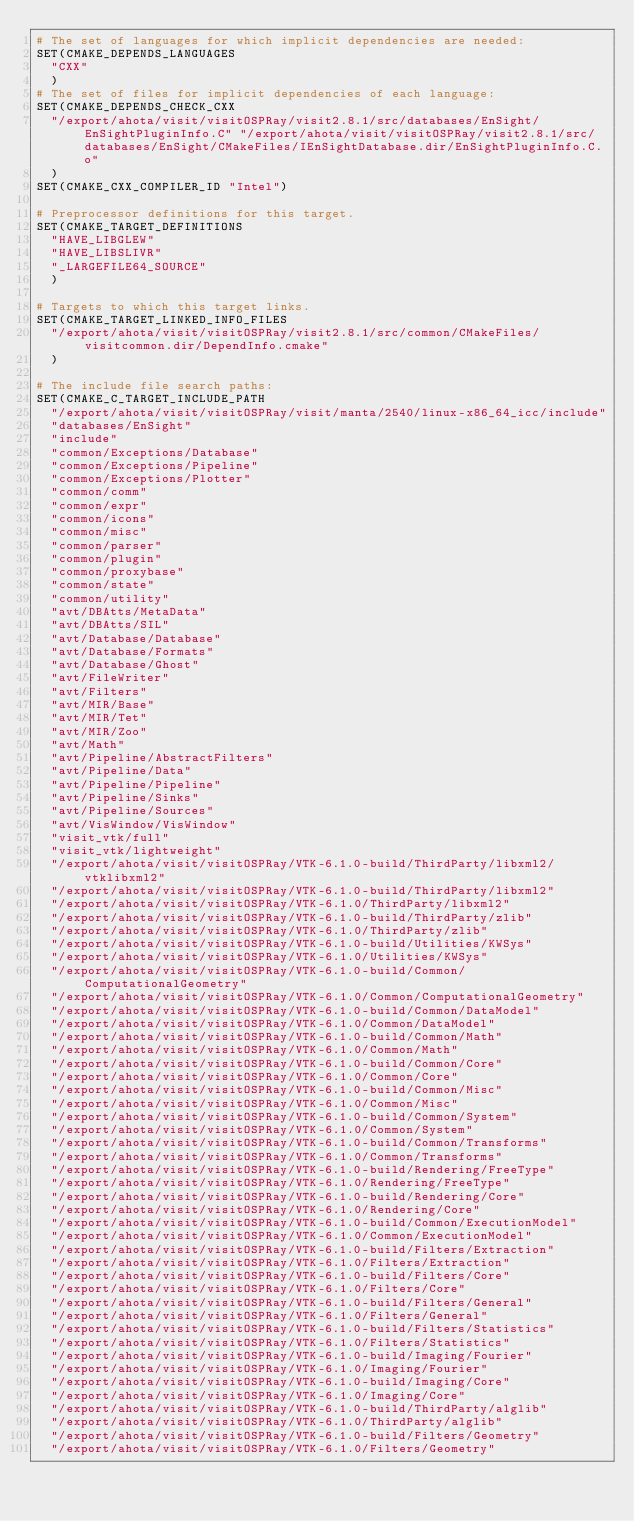<code> <loc_0><loc_0><loc_500><loc_500><_CMake_># The set of languages for which implicit dependencies are needed:
SET(CMAKE_DEPENDS_LANGUAGES
  "CXX"
  )
# The set of files for implicit dependencies of each language:
SET(CMAKE_DEPENDS_CHECK_CXX
  "/export/ahota/visit/visitOSPRay/visit2.8.1/src/databases/EnSight/EnSightPluginInfo.C" "/export/ahota/visit/visitOSPRay/visit2.8.1/src/databases/EnSight/CMakeFiles/IEnSightDatabase.dir/EnSightPluginInfo.C.o"
  )
SET(CMAKE_CXX_COMPILER_ID "Intel")

# Preprocessor definitions for this target.
SET(CMAKE_TARGET_DEFINITIONS
  "HAVE_LIBGLEW"
  "HAVE_LIBSLIVR"
  "_LARGEFILE64_SOURCE"
  )

# Targets to which this target links.
SET(CMAKE_TARGET_LINKED_INFO_FILES
  "/export/ahota/visit/visitOSPRay/visit2.8.1/src/common/CMakeFiles/visitcommon.dir/DependInfo.cmake"
  )

# The include file search paths:
SET(CMAKE_C_TARGET_INCLUDE_PATH
  "/export/ahota/visit/visitOSPRay/visit/manta/2540/linux-x86_64_icc/include"
  "databases/EnSight"
  "include"
  "common/Exceptions/Database"
  "common/Exceptions/Pipeline"
  "common/Exceptions/Plotter"
  "common/comm"
  "common/expr"
  "common/icons"
  "common/misc"
  "common/parser"
  "common/plugin"
  "common/proxybase"
  "common/state"
  "common/utility"
  "avt/DBAtts/MetaData"
  "avt/DBAtts/SIL"
  "avt/Database/Database"
  "avt/Database/Formats"
  "avt/Database/Ghost"
  "avt/FileWriter"
  "avt/Filters"
  "avt/MIR/Base"
  "avt/MIR/Tet"
  "avt/MIR/Zoo"
  "avt/Math"
  "avt/Pipeline/AbstractFilters"
  "avt/Pipeline/Data"
  "avt/Pipeline/Pipeline"
  "avt/Pipeline/Sinks"
  "avt/Pipeline/Sources"
  "avt/VisWindow/VisWindow"
  "visit_vtk/full"
  "visit_vtk/lightweight"
  "/export/ahota/visit/visitOSPRay/VTK-6.1.0-build/ThirdParty/libxml2/vtklibxml2"
  "/export/ahota/visit/visitOSPRay/VTK-6.1.0-build/ThirdParty/libxml2"
  "/export/ahota/visit/visitOSPRay/VTK-6.1.0/ThirdParty/libxml2"
  "/export/ahota/visit/visitOSPRay/VTK-6.1.0-build/ThirdParty/zlib"
  "/export/ahota/visit/visitOSPRay/VTK-6.1.0/ThirdParty/zlib"
  "/export/ahota/visit/visitOSPRay/VTK-6.1.0-build/Utilities/KWSys"
  "/export/ahota/visit/visitOSPRay/VTK-6.1.0/Utilities/KWSys"
  "/export/ahota/visit/visitOSPRay/VTK-6.1.0-build/Common/ComputationalGeometry"
  "/export/ahota/visit/visitOSPRay/VTK-6.1.0/Common/ComputationalGeometry"
  "/export/ahota/visit/visitOSPRay/VTK-6.1.0-build/Common/DataModel"
  "/export/ahota/visit/visitOSPRay/VTK-6.1.0/Common/DataModel"
  "/export/ahota/visit/visitOSPRay/VTK-6.1.0-build/Common/Math"
  "/export/ahota/visit/visitOSPRay/VTK-6.1.0/Common/Math"
  "/export/ahota/visit/visitOSPRay/VTK-6.1.0-build/Common/Core"
  "/export/ahota/visit/visitOSPRay/VTK-6.1.0/Common/Core"
  "/export/ahota/visit/visitOSPRay/VTK-6.1.0-build/Common/Misc"
  "/export/ahota/visit/visitOSPRay/VTK-6.1.0/Common/Misc"
  "/export/ahota/visit/visitOSPRay/VTK-6.1.0-build/Common/System"
  "/export/ahota/visit/visitOSPRay/VTK-6.1.0/Common/System"
  "/export/ahota/visit/visitOSPRay/VTK-6.1.0-build/Common/Transforms"
  "/export/ahota/visit/visitOSPRay/VTK-6.1.0/Common/Transforms"
  "/export/ahota/visit/visitOSPRay/VTK-6.1.0-build/Rendering/FreeType"
  "/export/ahota/visit/visitOSPRay/VTK-6.1.0/Rendering/FreeType"
  "/export/ahota/visit/visitOSPRay/VTK-6.1.0-build/Rendering/Core"
  "/export/ahota/visit/visitOSPRay/VTK-6.1.0/Rendering/Core"
  "/export/ahota/visit/visitOSPRay/VTK-6.1.0-build/Common/ExecutionModel"
  "/export/ahota/visit/visitOSPRay/VTK-6.1.0/Common/ExecutionModel"
  "/export/ahota/visit/visitOSPRay/VTK-6.1.0-build/Filters/Extraction"
  "/export/ahota/visit/visitOSPRay/VTK-6.1.0/Filters/Extraction"
  "/export/ahota/visit/visitOSPRay/VTK-6.1.0-build/Filters/Core"
  "/export/ahota/visit/visitOSPRay/VTK-6.1.0/Filters/Core"
  "/export/ahota/visit/visitOSPRay/VTK-6.1.0-build/Filters/General"
  "/export/ahota/visit/visitOSPRay/VTK-6.1.0/Filters/General"
  "/export/ahota/visit/visitOSPRay/VTK-6.1.0-build/Filters/Statistics"
  "/export/ahota/visit/visitOSPRay/VTK-6.1.0/Filters/Statistics"
  "/export/ahota/visit/visitOSPRay/VTK-6.1.0-build/Imaging/Fourier"
  "/export/ahota/visit/visitOSPRay/VTK-6.1.0/Imaging/Fourier"
  "/export/ahota/visit/visitOSPRay/VTK-6.1.0-build/Imaging/Core"
  "/export/ahota/visit/visitOSPRay/VTK-6.1.0/Imaging/Core"
  "/export/ahota/visit/visitOSPRay/VTK-6.1.0-build/ThirdParty/alglib"
  "/export/ahota/visit/visitOSPRay/VTK-6.1.0/ThirdParty/alglib"
  "/export/ahota/visit/visitOSPRay/VTK-6.1.0-build/Filters/Geometry"
  "/export/ahota/visit/visitOSPRay/VTK-6.1.0/Filters/Geometry"</code> 